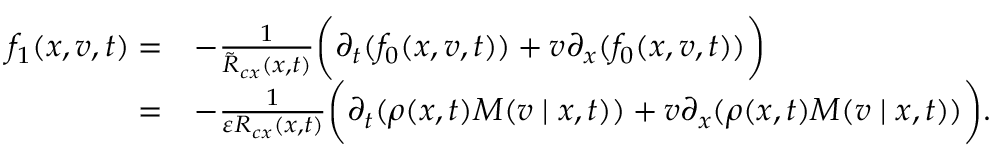Convert formula to latex. <formula><loc_0><loc_0><loc_500><loc_500>\begin{array} { r l } { f _ { 1 } ( x , v , t ) = } & { - \frac { 1 } { \tilde { R } _ { c x } ( x , t ) } \left ( \partial _ { t } ( f _ { 0 } ( x , v , t ) ) + v \partial _ { x } ( f _ { 0 } ( x , v , t ) ) \right ) } \\ { = } & { - \frac { 1 } { \varepsilon R _ { c x } ( x , t ) } \left ( \partial _ { t } ( \rho ( x , t ) M ( v | x , t ) ) + v \partial _ { x } ( \rho ( x , t ) M ( v | x , t ) ) \right ) . } \end{array}</formula> 